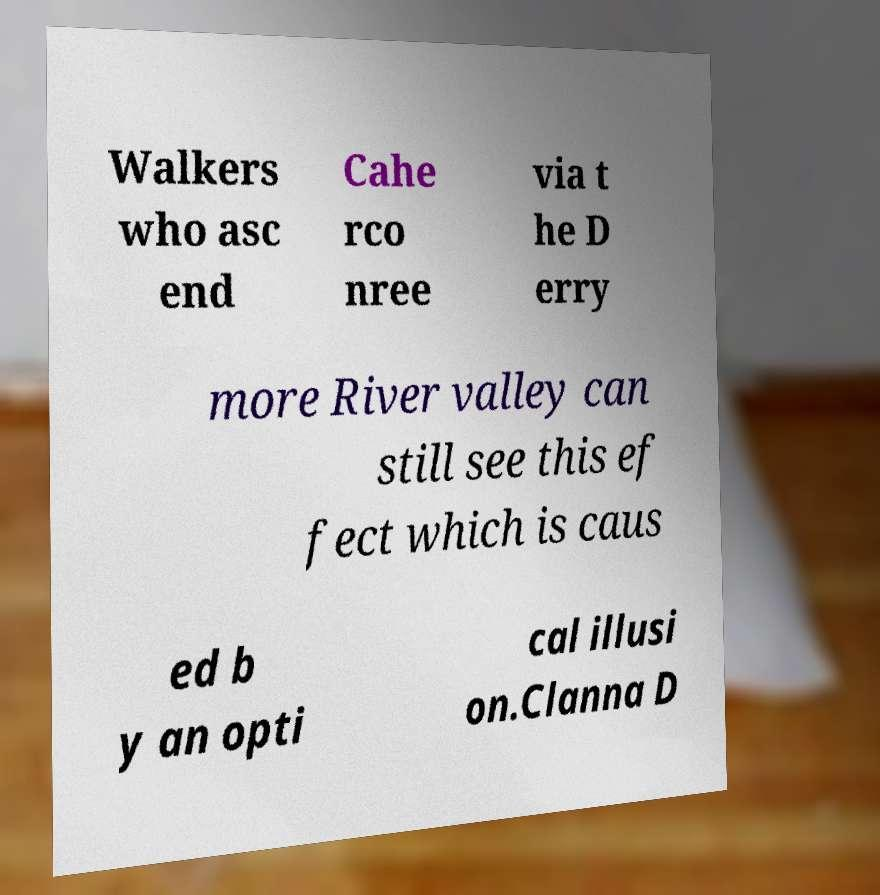Could you assist in decoding the text presented in this image and type it out clearly? Walkers who asc end Cahe rco nree via t he D erry more River valley can still see this ef fect which is caus ed b y an opti cal illusi on.Clanna D 